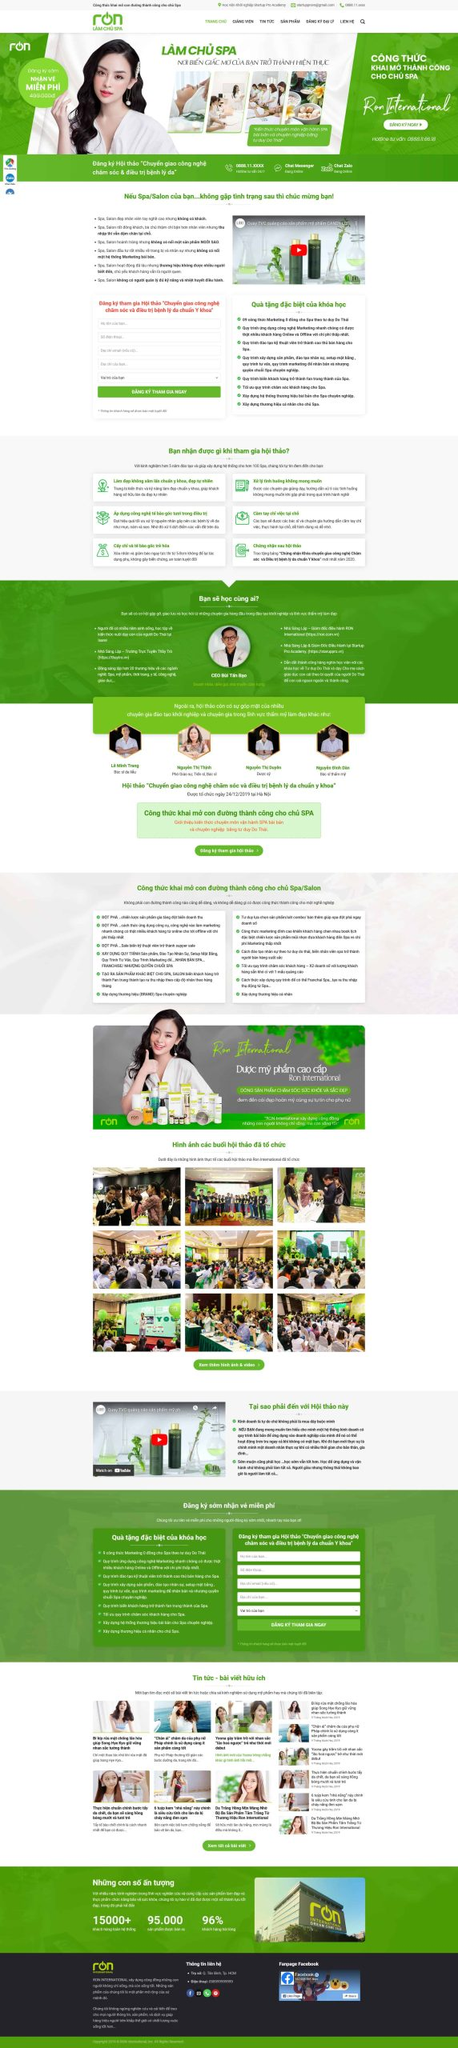Liệt kê 5 ngành nghề, lĩnh vực phù hợp với website này, phân cách các màu sắc bằng dấu phẩy. Chỉ trả về kết quả, phân cách bằng dấy phẩy
 Spa, Salon, Chăm sóc sắc đẹp, Mỹ phẩm, Đào tạo nghề spa 